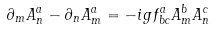<formula> <loc_0><loc_0><loc_500><loc_500>\partial _ { m } A _ { n } ^ { a } - \partial _ { n } A _ { m } ^ { a } = - i g f _ { b c } ^ { a } A _ { m } ^ { b } A _ { n } ^ { c }</formula> 